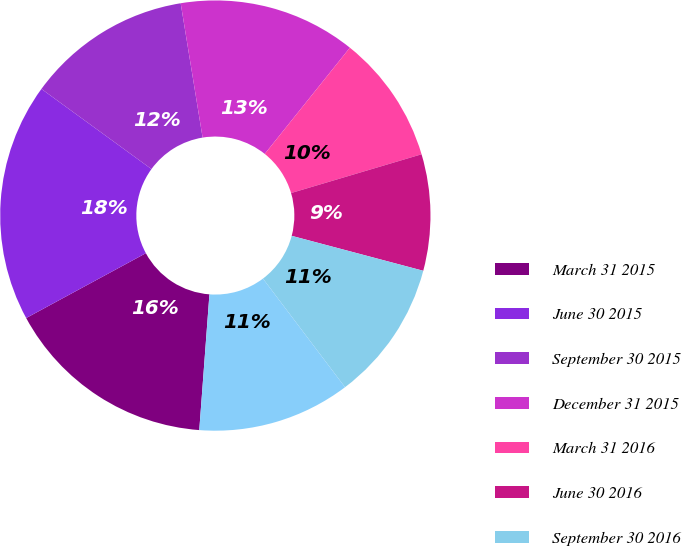<chart> <loc_0><loc_0><loc_500><loc_500><pie_chart><fcel>March 31 2015<fcel>June 30 2015<fcel>September 30 2015<fcel>December 31 2015<fcel>March 31 2016<fcel>June 30 2016<fcel>September 30 2016<fcel>December 31 2016<nl><fcel>15.91%<fcel>17.92%<fcel>12.41%<fcel>13.33%<fcel>9.65%<fcel>8.73%<fcel>10.57%<fcel>11.49%<nl></chart> 